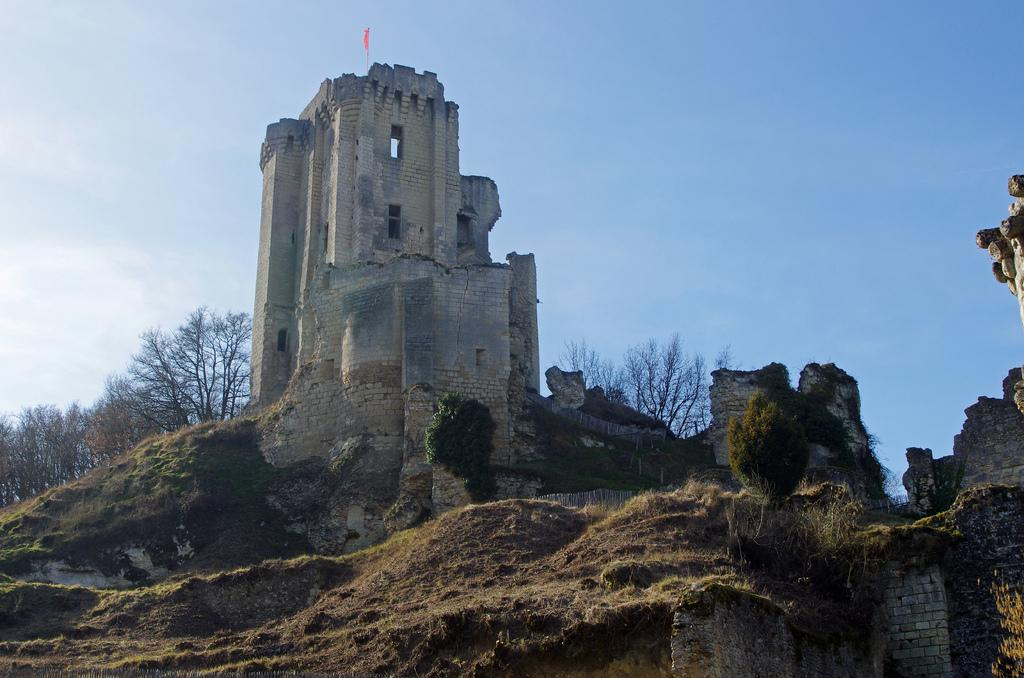What type of structure is the main subject of the image? There is a fort in the image. What can be seen in the background of the image? There are many trees in the background of the image. Are there any plants visible in the image? Yes, there are plants in the image. What is the composition of the fort's perimeter? There is a wall surrounding the fort in the image. What is flying at the top of the fort? There is a flag with a pole in the top of the image. What is visible in the sky in the image? The sky is visible in the top of the image. How many girls are offering lip balm in the image? There are no girls or lip balm present in the image. 